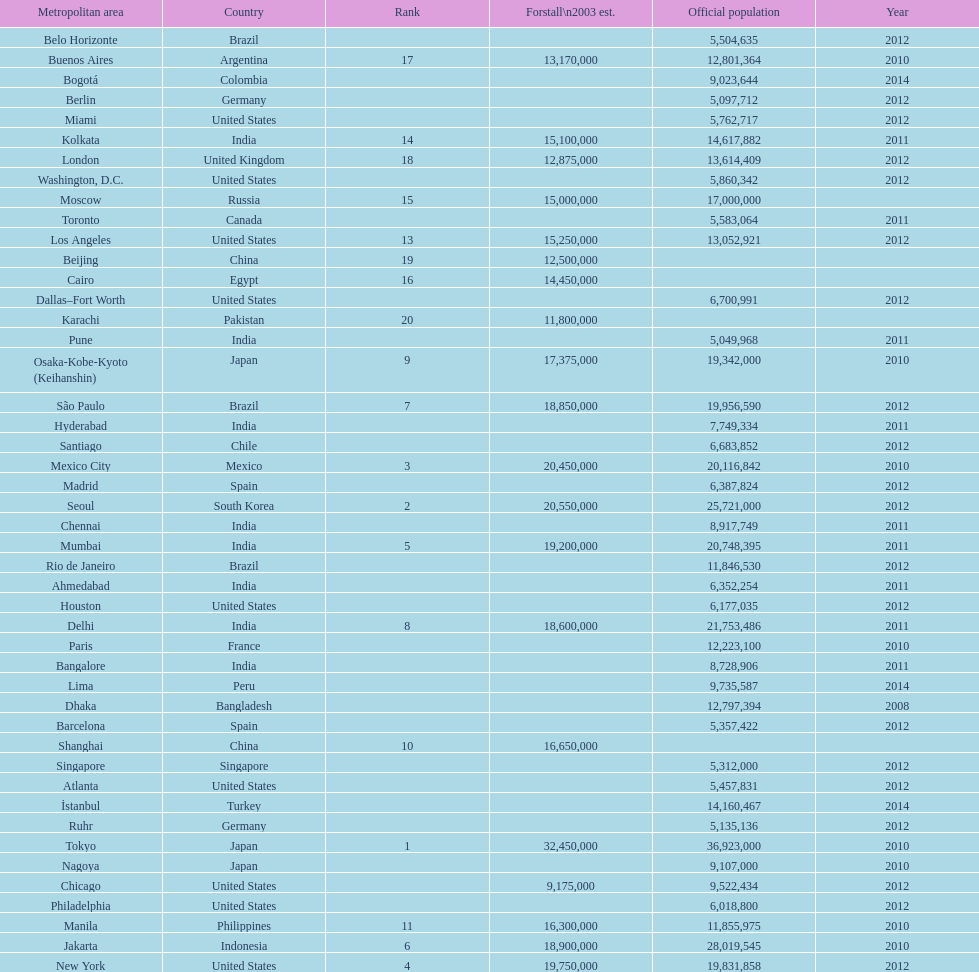Which population is listed before 5,357,422? 8,728,906. 